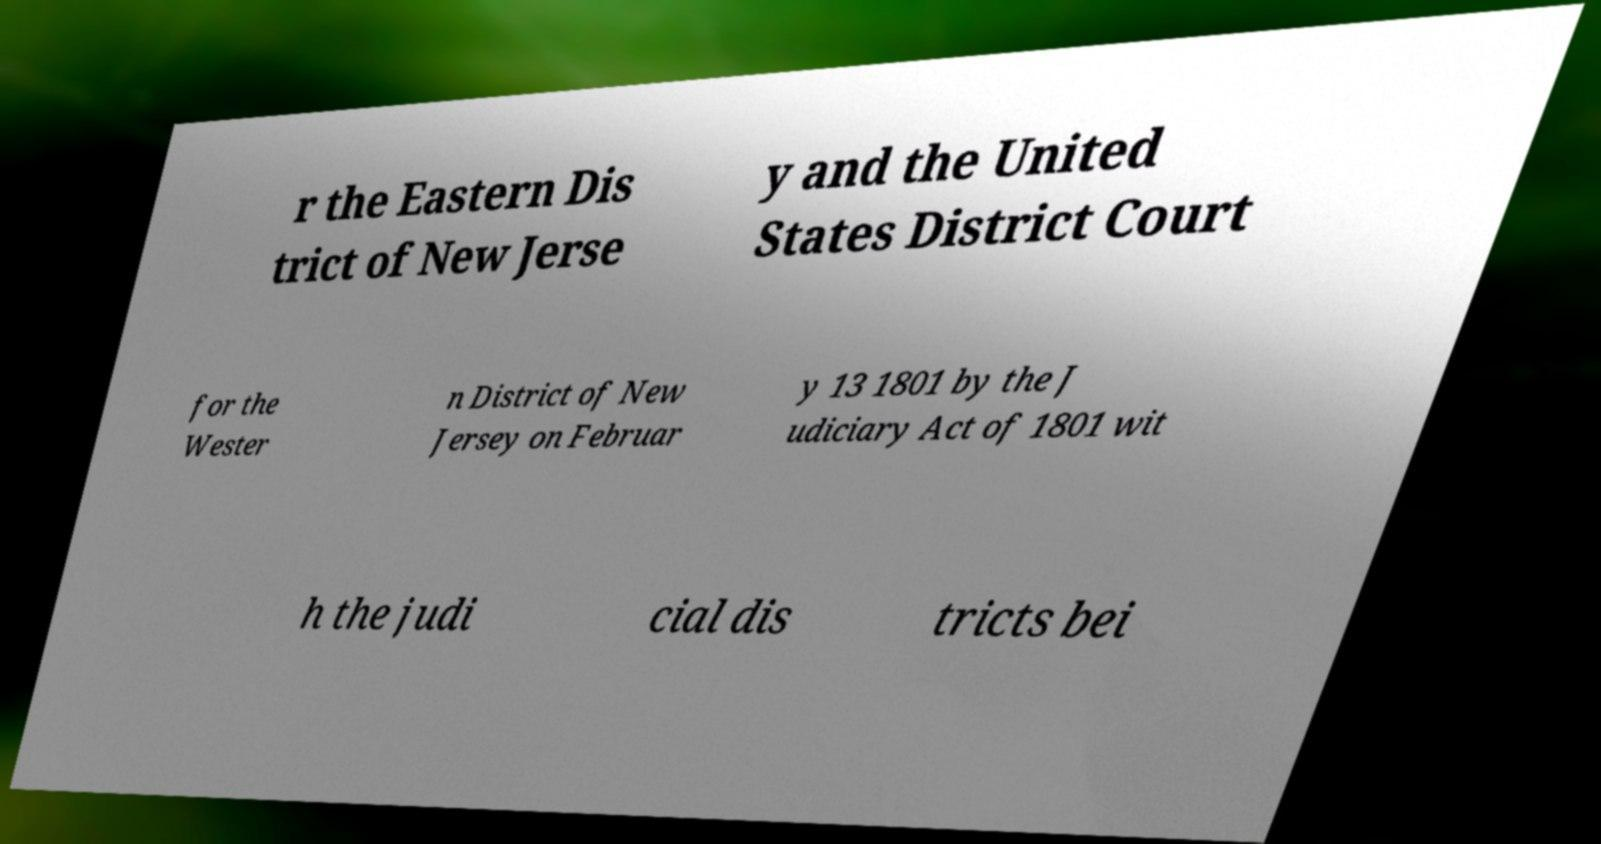What messages or text are displayed in this image? I need them in a readable, typed format. r the Eastern Dis trict of New Jerse y and the United States District Court for the Wester n District of New Jersey on Februar y 13 1801 by the J udiciary Act of 1801 wit h the judi cial dis tricts bei 